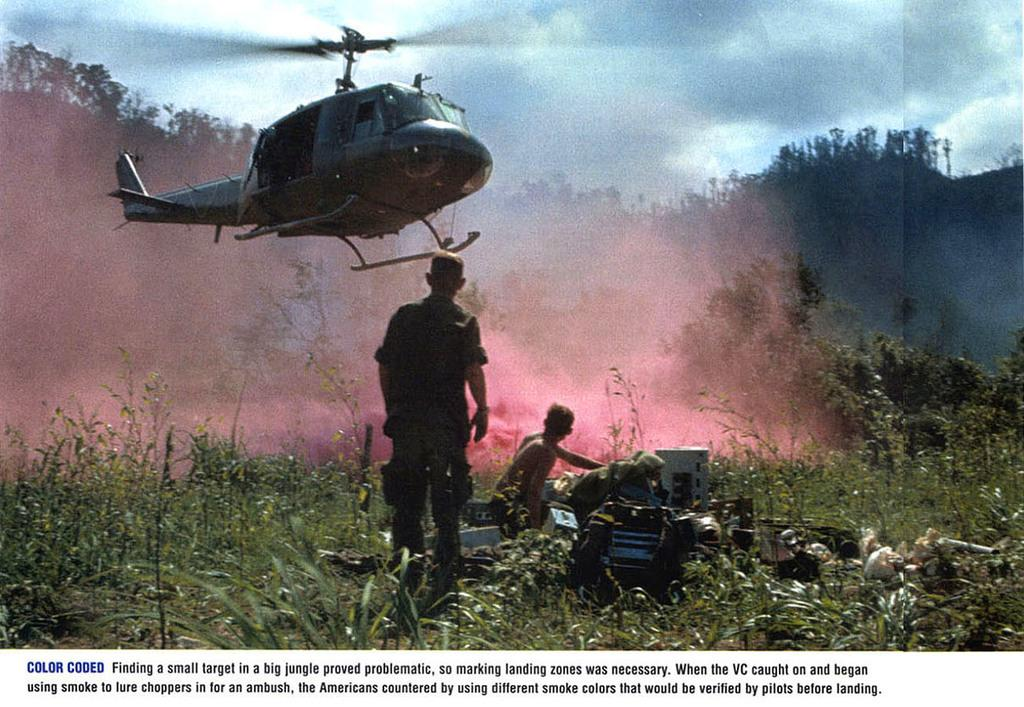<image>
Present a compact description of the photo's key features. A photograph documenting a moment from the Vietnam War is titled Color Coded. 